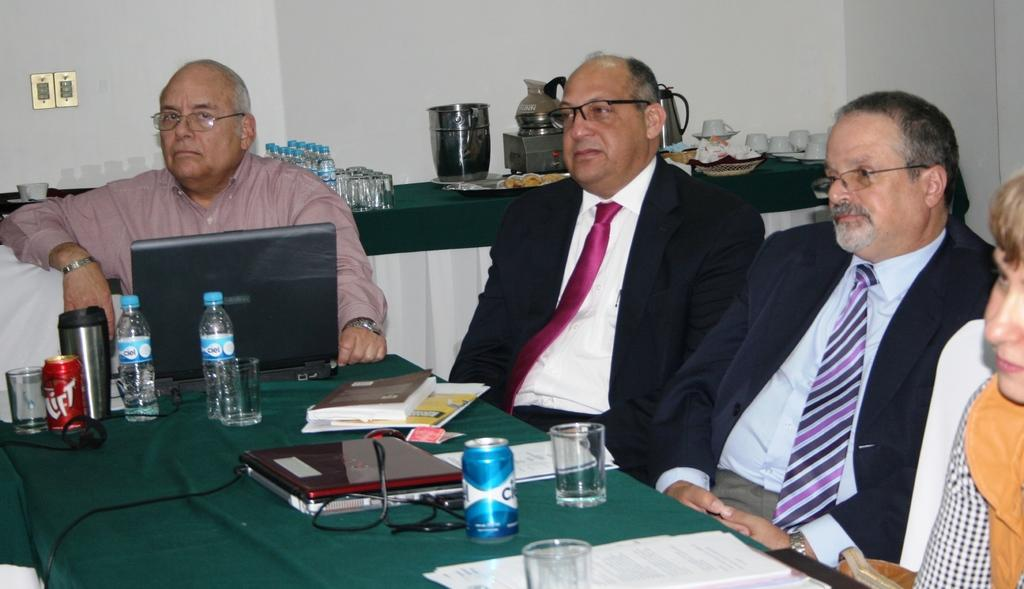How many people are sitting in the image? There are four persons sitting on chairs in the image. What objects can be seen on the table in the image? On the table, there is a glass, a laptop, a bottle, and a book. Where is the park located in the image? There is no park present in the image. What type of canvas is being used for the art in the image? There is no canvas or art present in the image. 